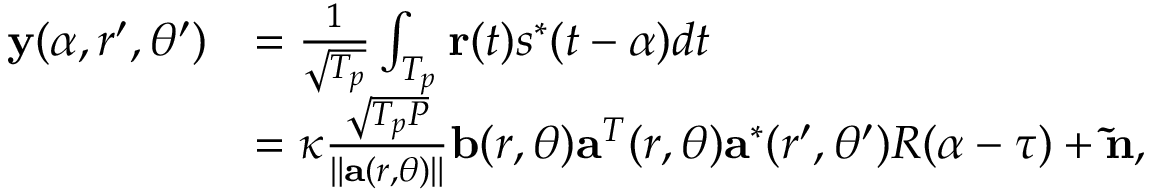Convert formula to latex. <formula><loc_0><loc_0><loc_500><loc_500>\begin{array} { r l } { { y } ( \alpha , r ^ { \prime } , \theta ^ { \prime } ) } & { = \frac { 1 } { { \sqrt { T _ { p } } } } \int _ { { T _ { p } } } { { r } ( t ) { s ^ { * } } ( t - \alpha ) } d t } \\ & { = \kappa \frac { { \sqrt { { T _ { p } } P } } } { { \| { { a } ( r , \theta ) } \| } } { b } ( r , \theta ) { { a } ^ { T } } ( r , \theta ) { { a } ^ { * } } ( r ^ { \prime } , \theta ^ { \prime } ) R ( \alpha - \tau ) + { \tilde { n } } , } \end{array}</formula> 